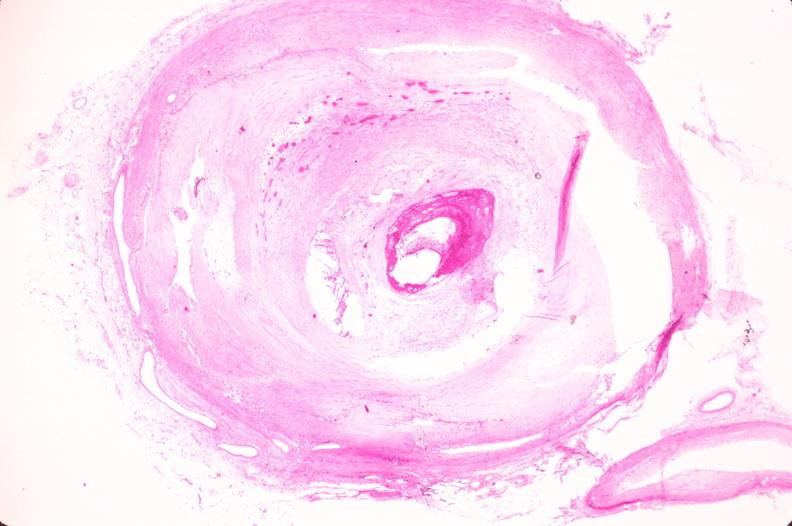s vasculature present?
Answer the question using a single word or phrase. Yes 